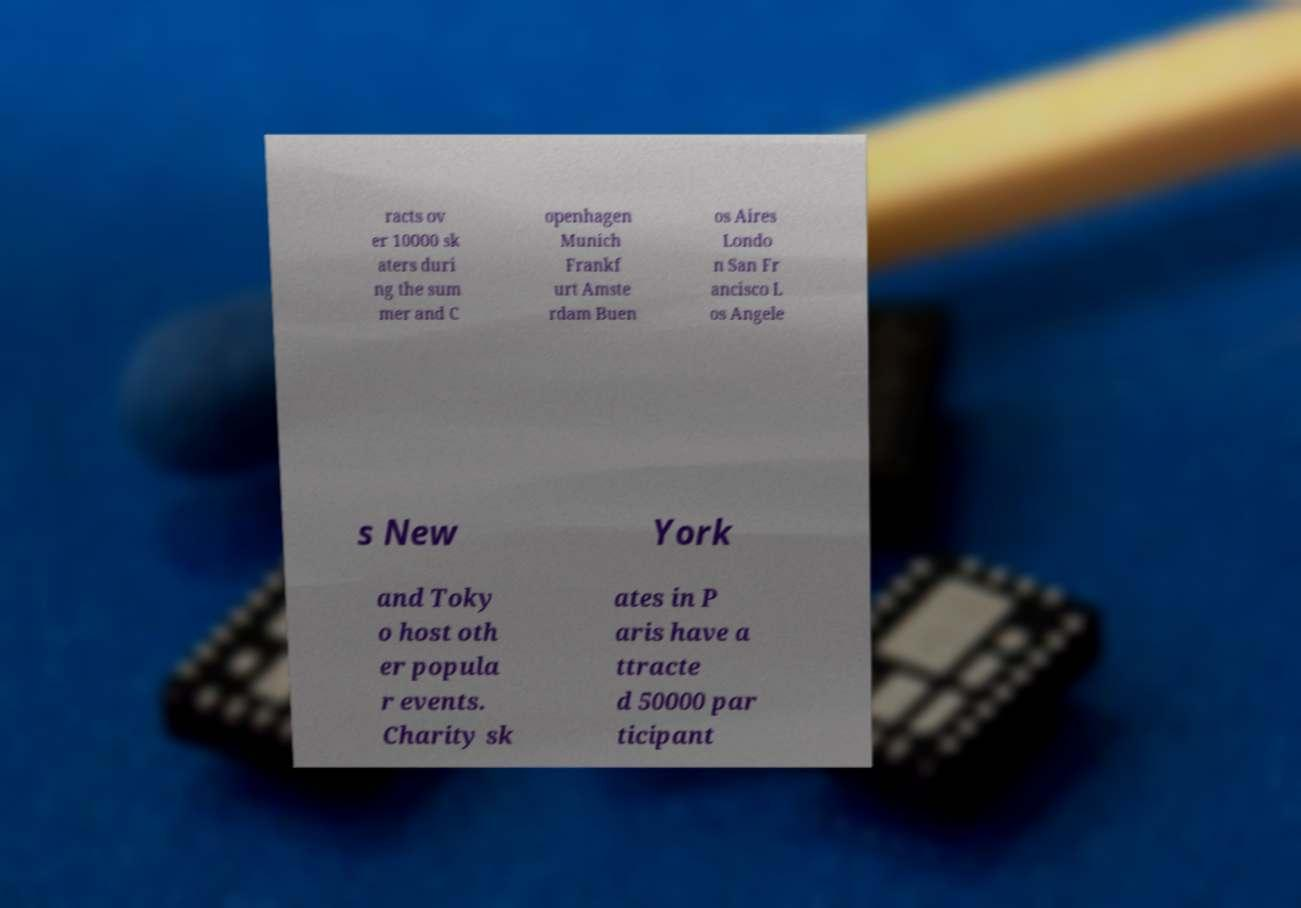What messages or text are displayed in this image? I need them in a readable, typed format. racts ov er 10000 sk aters duri ng the sum mer and C openhagen Munich Frankf urt Amste rdam Buen os Aires Londo n San Fr ancisco L os Angele s New York and Toky o host oth er popula r events. Charity sk ates in P aris have a ttracte d 50000 par ticipant 